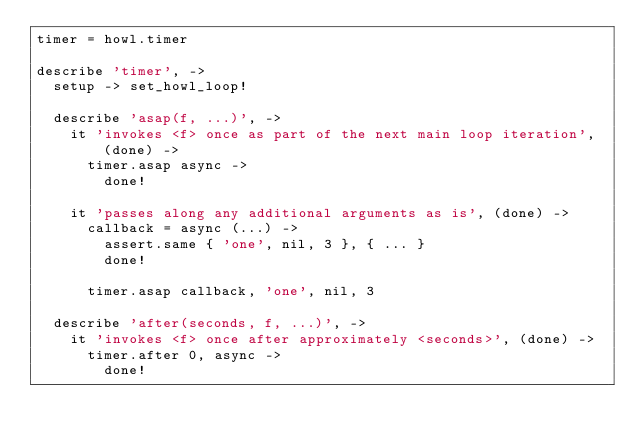Convert code to text. <code><loc_0><loc_0><loc_500><loc_500><_MoonScript_>timer = howl.timer

describe 'timer', ->
  setup -> set_howl_loop!

  describe 'asap(f, ...)', ->
    it 'invokes <f> once as part of the next main loop iteration', (done) ->
      timer.asap async ->
        done!

    it 'passes along any additional arguments as is', (done) ->
      callback = async (...) ->
        assert.same { 'one', nil, 3 }, { ... }
        done!

      timer.asap callback, 'one', nil, 3

  describe 'after(seconds, f, ...)', ->
    it 'invokes <f> once after approximately <seconds>', (done) ->
      timer.after 0, async ->
        done!
</code> 